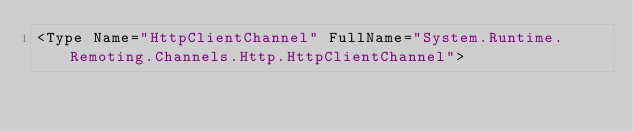Convert code to text. <code><loc_0><loc_0><loc_500><loc_500><_XML_><Type Name="HttpClientChannel" FullName="System.Runtime.Remoting.Channels.Http.HttpClientChannel"></code> 